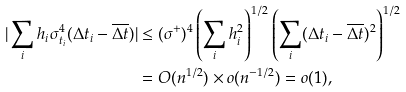<formula> <loc_0><loc_0><loc_500><loc_500>| \sum _ { i } h _ { i } \sigma ^ { 4 } _ { t _ { i } } ( \Delta t _ { i } - \overline { \Delta t } ) | & \leq ( \sigma ^ { + } ) ^ { 4 } \left ( \sum _ { i } h _ { i } ^ { 2 } \right ) ^ { 1 / 2 } \left ( \sum _ { i } ( \Delta t _ { i } - \overline { \Delta t } ) ^ { 2 } \right ) ^ { 1 / 2 } \\ & = O ( n ^ { 1 / 2 } ) \times o ( n ^ { - 1 / 2 } ) = o ( 1 ) ,</formula> 